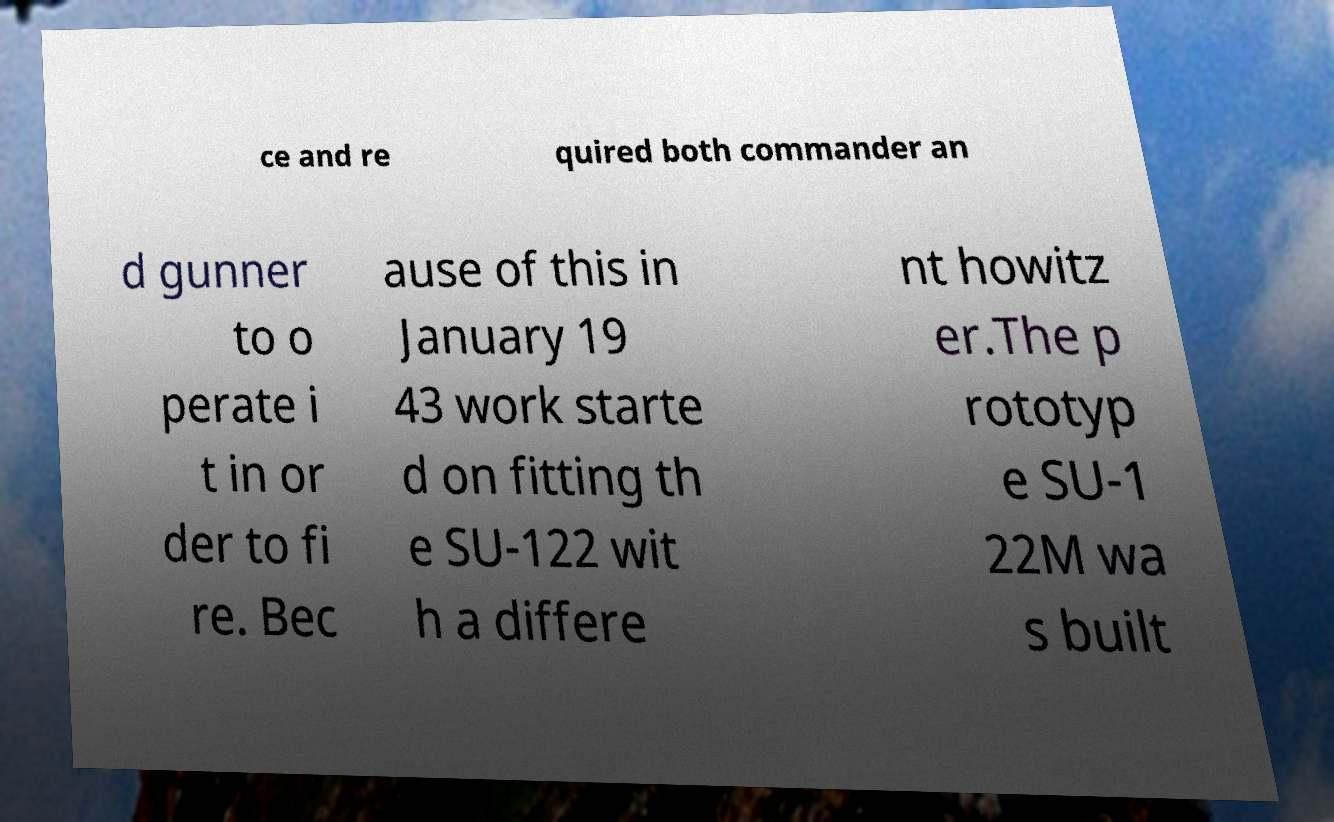What messages or text are displayed in this image? I need them in a readable, typed format. ce and re quired both commander an d gunner to o perate i t in or der to fi re. Bec ause of this in January 19 43 work starte d on fitting th e SU-122 wit h a differe nt howitz er.The p rototyp e SU-1 22M wa s built 